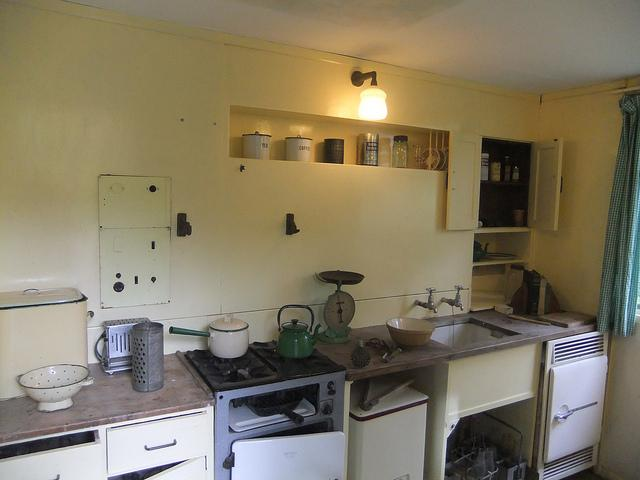What is the white bowl with holes in it on the left used for? Please explain your reasoning. straining. The white bowl is a colander and is used to drain liquids away from food. 